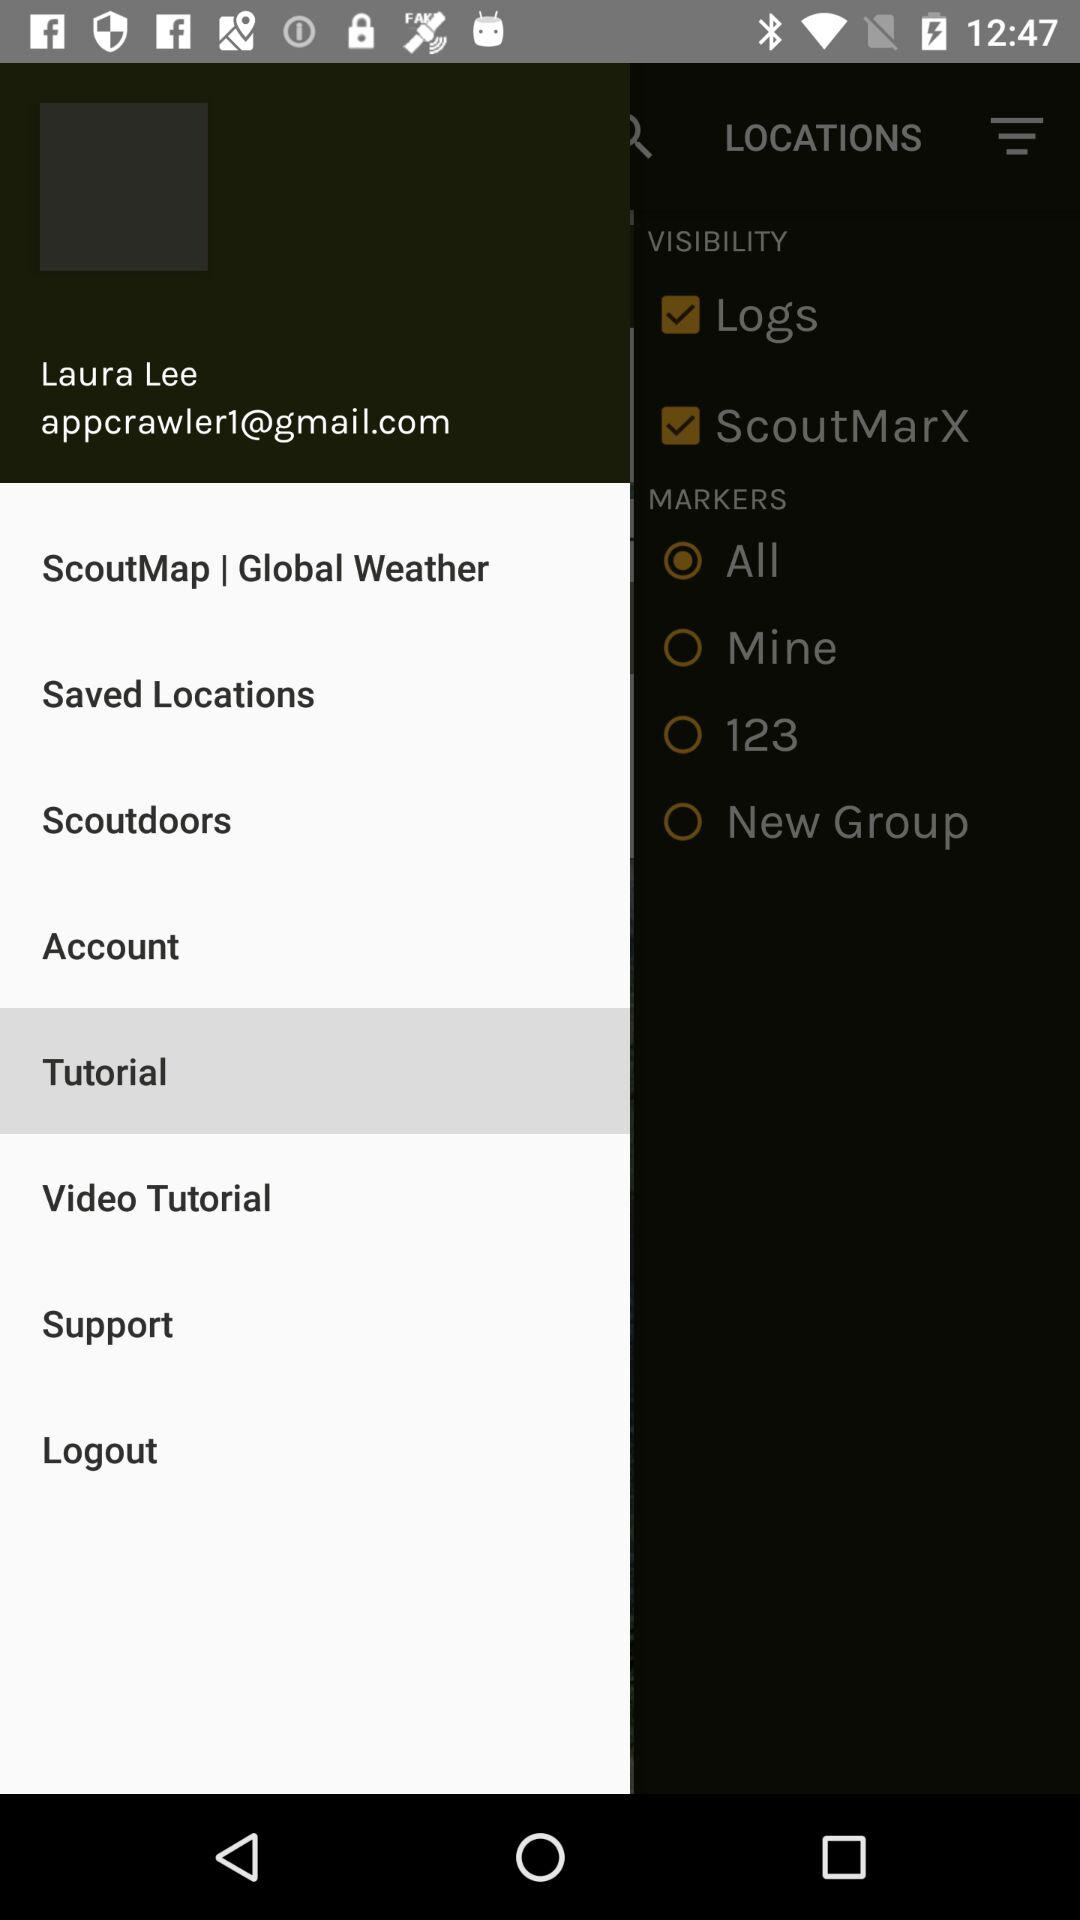What's the user name? The user name is "Laura Lee". 